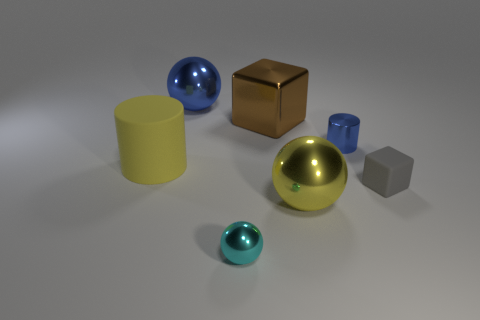Add 2 yellow matte things. How many objects exist? 9 Subtract all cylinders. How many objects are left? 5 Subtract all cyan metallic things. Subtract all big yellow metal objects. How many objects are left? 5 Add 5 large metal things. How many large metal things are left? 8 Add 1 yellow metal things. How many yellow metal things exist? 2 Subtract 0 green blocks. How many objects are left? 7 